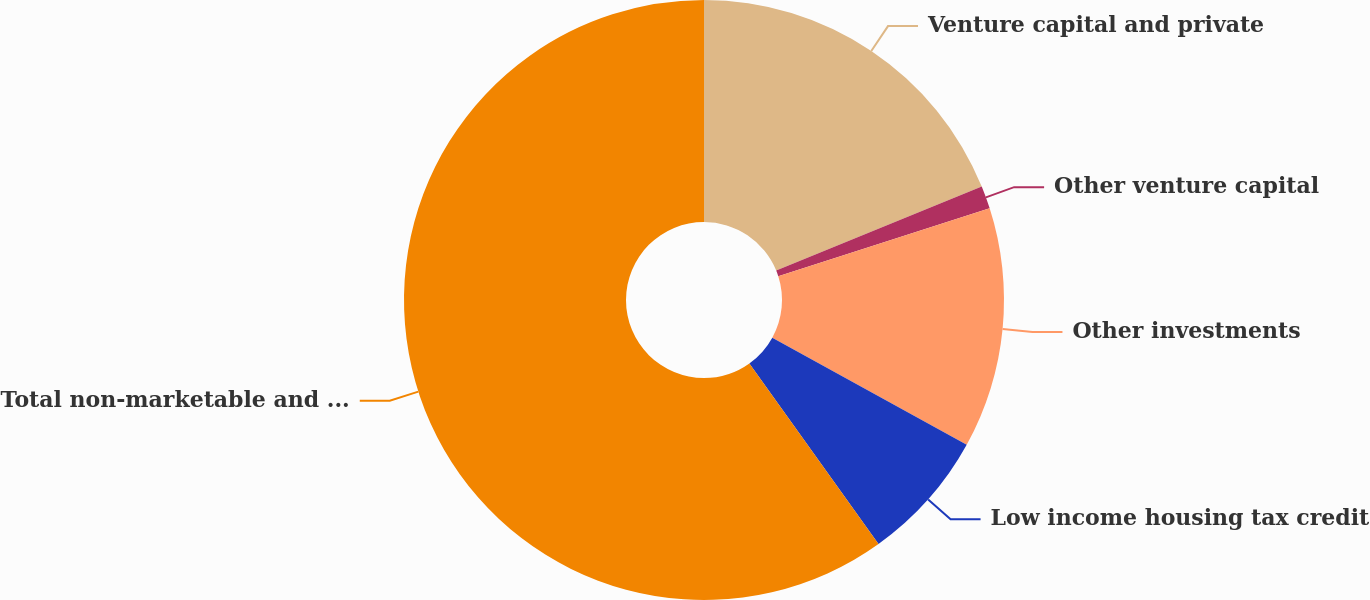<chart> <loc_0><loc_0><loc_500><loc_500><pie_chart><fcel>Venture capital and private<fcel>Other venture capital<fcel>Other investments<fcel>Low income housing tax credit<fcel>Total non-marketable and other<nl><fcel>18.83%<fcel>1.23%<fcel>12.96%<fcel>7.1%<fcel>59.88%<nl></chart> 